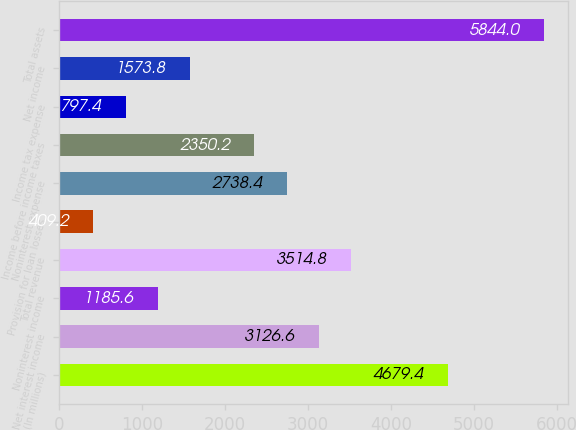<chart> <loc_0><loc_0><loc_500><loc_500><bar_chart><fcel>(In millions)<fcel>Net interest income<fcel>Noninterest income<fcel>Total revenue<fcel>Provision for loan losses<fcel>Noninterest expense<fcel>Income before income taxes<fcel>Income tax expense<fcel>Net income<fcel>Total assets<nl><fcel>4679.4<fcel>3126.6<fcel>1185.6<fcel>3514.8<fcel>409.2<fcel>2738.4<fcel>2350.2<fcel>797.4<fcel>1573.8<fcel>5844<nl></chart> 